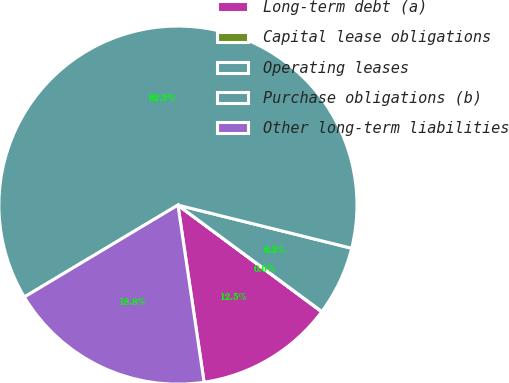Convert chart to OTSL. <chart><loc_0><loc_0><loc_500><loc_500><pie_chart><fcel>Long-term debt (a)<fcel>Capital lease obligations<fcel>Operating leases<fcel>Purchase obligations (b)<fcel>Other long-term liabilities<nl><fcel>12.51%<fcel>0.02%<fcel>6.26%<fcel>62.46%<fcel>18.75%<nl></chart> 